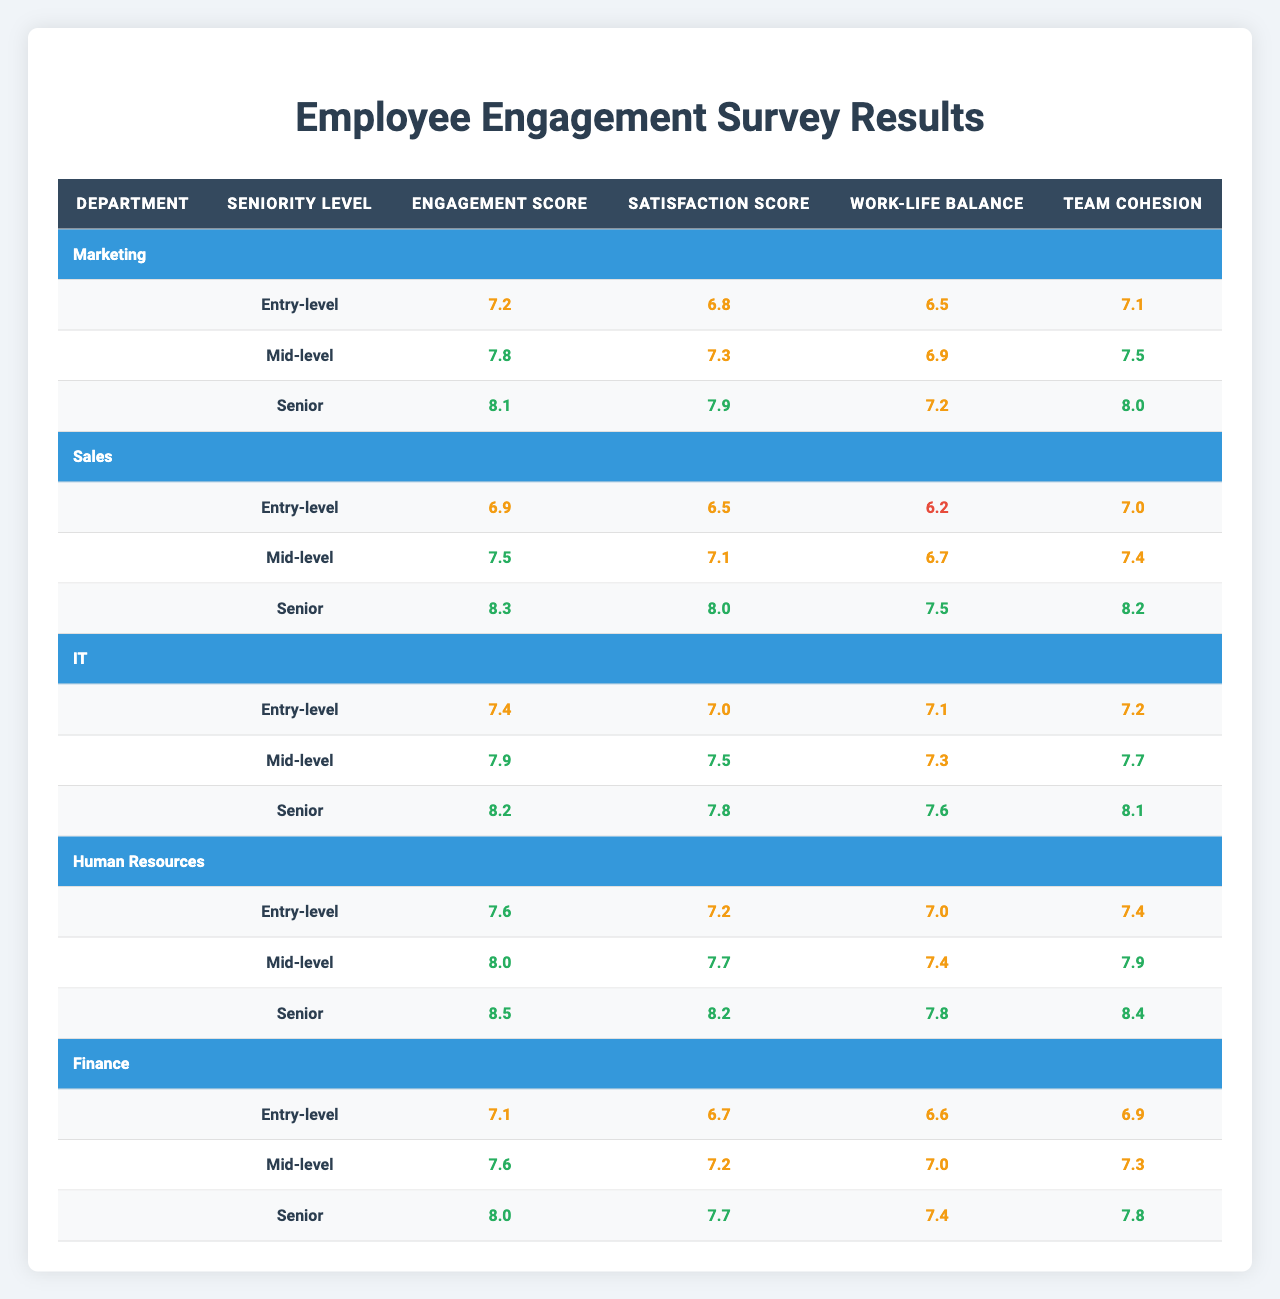What is the engagement score for Senior-level employees in the IT department? The table states that the engagement score for Senior-level employees in the IT department is 8.2.
Answer: 8.2 Which department has the highest engagement score for Mid-level employees? The Mid-level engagement scores across departments are: Marketing (7.8), Sales (7.5), IT (7.9), Human Resources (8.0), and Finance (7.6). The highest score is from the Human Resources department at 8.0.
Answer: Human Resources What is the average satisfaction score for Entry-level employees across all departments? The satisfaction scores for Entry-level employees are: Marketing (6.8), Sales (6.5), IT (7.0), Human Resources (7.2), and Finance (6.7). Adding these scores together gives 6.8 + 6.5 + 7.0 + 7.2 + 6.7 = 34.2, and dividing by the number of departments (5) results in an average of 34.2 / 5 = 6.84.
Answer: 6.84 Is the work-life balance score for Senior-level employees in Sales higher than that in Finance? The work-life balance score for Senior-level employees in Sales is 7.5, while in Finance it is 7.4. Since 7.5 is greater than 7.4, the statement is true.
Answer: Yes What is the difference in team cohesion scores between Entry-level employees in Marketing and IT? The team cohesion score for Entry-level employees in Marketing is 7.1, while for IT it is 7.2. The difference is 7.2 - 7.1 = 0.1.
Answer: 0.1 Which seniority level in the Human Resources department has the highest satisfaction score? The satisfaction scores in the Human Resources department by seniority are: Entry-level (7.2), Mid-level (7.7), and Senior (8.2). The highest score is from Senior-level employees at 8.2.
Answer: Senior What is the overall average engagement score for Mid-level employees across all departments? The engagement scores for Mid-level employees are: Marketing (7.8), Sales (7.5), IT (7.9), Human Resources (8.0), and Finance (7.6). Summing these gives 7.8 + 7.5 + 7.9 + 8.0 + 7.6 = 38.8. Dividing by the number of departments (5) results in an average of 38.8 / 5 = 7.76.
Answer: 7.76 Does the IT department have a work-life balance score that is above the average of all Entry-level work-life balance scores? The work-life balance scores for Entry-level employees are: Marketing (6.5), Sales (6.2), IT (7.1), Human Resources (7.0), and Finance (6.6). Their average is (6.5 + 6.2 + 7.1 + 7.0 + 6.6) / 5 = 6.68. Since IT's score of 7.1 is greater than 6.68, the answer is yes.
Answer: Yes Which department shows the largest improvement in engagement scores from Entry-level to Senior-level? For each department, the improvement is calculated as follows: Marketing (8.1 - 7.2 = 0.9), Sales (8.3 - 6.9 = 1.4), IT (8.2 - 7.4 = 0.8), Human Resources (8.5 - 7.6 = 0.9), and Finance (8.0 - 7.1 = 0.9). The largest improvement is from Sales at 1.4.
Answer: Sales 